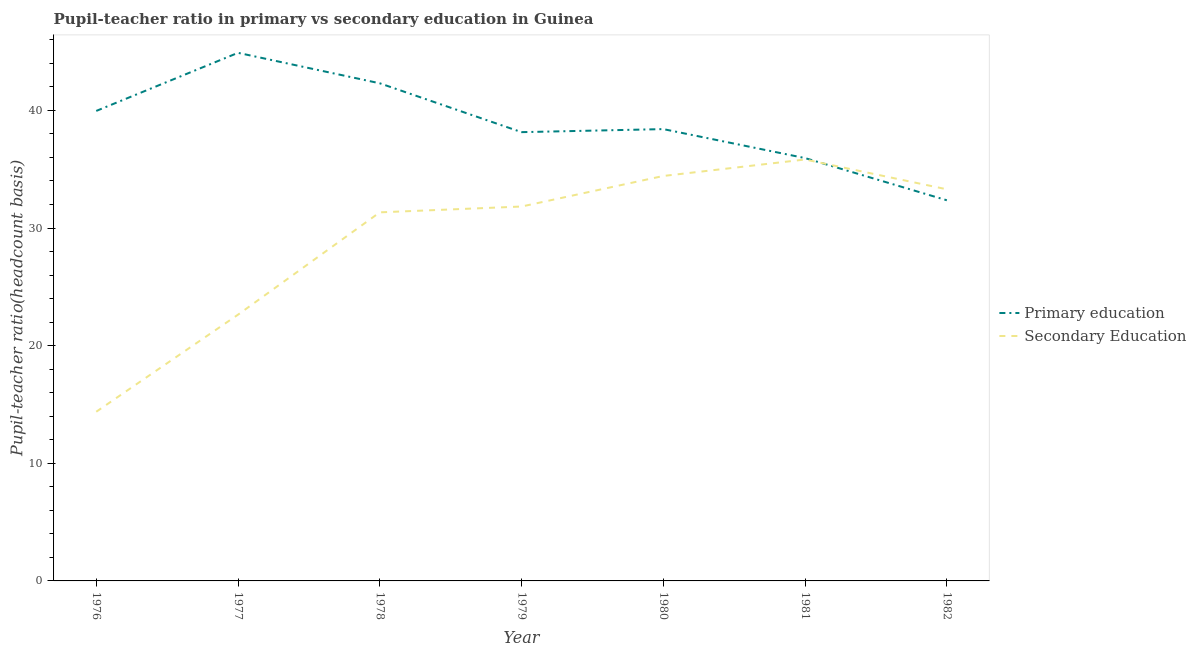How many different coloured lines are there?
Provide a short and direct response. 2. Is the number of lines equal to the number of legend labels?
Offer a terse response. Yes. What is the pupil-teacher ratio in primary education in 1981?
Keep it short and to the point. 35.95. Across all years, what is the maximum pupil teacher ratio on secondary education?
Keep it short and to the point. 35.83. Across all years, what is the minimum pupil-teacher ratio in primary education?
Your response must be concise. 32.36. In which year was the pupil-teacher ratio in primary education maximum?
Offer a very short reply. 1977. What is the total pupil teacher ratio on secondary education in the graph?
Give a very brief answer. 203.72. What is the difference between the pupil-teacher ratio in primary education in 1978 and that in 1982?
Offer a very short reply. 9.94. What is the difference between the pupil-teacher ratio in primary education in 1981 and the pupil teacher ratio on secondary education in 1982?
Offer a very short reply. 2.65. What is the average pupil teacher ratio on secondary education per year?
Keep it short and to the point. 29.1. In the year 1979, what is the difference between the pupil-teacher ratio in primary education and pupil teacher ratio on secondary education?
Your answer should be compact. 6.32. What is the ratio of the pupil-teacher ratio in primary education in 1976 to that in 1978?
Offer a very short reply. 0.94. Is the pupil teacher ratio on secondary education in 1977 less than that in 1979?
Your answer should be very brief. Yes. Is the difference between the pupil teacher ratio on secondary education in 1977 and 1978 greater than the difference between the pupil-teacher ratio in primary education in 1977 and 1978?
Ensure brevity in your answer.  No. What is the difference between the highest and the second highest pupil-teacher ratio in primary education?
Provide a succinct answer. 2.59. What is the difference between the highest and the lowest pupil-teacher ratio in primary education?
Your answer should be very brief. 12.54. Is the pupil teacher ratio on secondary education strictly greater than the pupil-teacher ratio in primary education over the years?
Provide a short and direct response. No. Is the pupil teacher ratio on secondary education strictly less than the pupil-teacher ratio in primary education over the years?
Your answer should be compact. No. What is the difference between two consecutive major ticks on the Y-axis?
Offer a terse response. 10. Does the graph contain grids?
Provide a short and direct response. No. Where does the legend appear in the graph?
Keep it short and to the point. Center right. How are the legend labels stacked?
Your response must be concise. Vertical. What is the title of the graph?
Give a very brief answer. Pupil-teacher ratio in primary vs secondary education in Guinea. What is the label or title of the Y-axis?
Give a very brief answer. Pupil-teacher ratio(headcount basis). What is the Pupil-teacher ratio(headcount basis) of Primary education in 1976?
Your response must be concise. 39.95. What is the Pupil-teacher ratio(headcount basis) of Secondary Education in 1976?
Offer a very short reply. 14.38. What is the Pupil-teacher ratio(headcount basis) in Primary education in 1977?
Offer a terse response. 44.89. What is the Pupil-teacher ratio(headcount basis) of Secondary Education in 1977?
Offer a very short reply. 22.63. What is the Pupil-teacher ratio(headcount basis) in Primary education in 1978?
Your answer should be very brief. 42.3. What is the Pupil-teacher ratio(headcount basis) of Secondary Education in 1978?
Provide a succinct answer. 31.33. What is the Pupil-teacher ratio(headcount basis) of Primary education in 1979?
Your answer should be very brief. 38.15. What is the Pupil-teacher ratio(headcount basis) of Secondary Education in 1979?
Your answer should be very brief. 31.83. What is the Pupil-teacher ratio(headcount basis) in Primary education in 1980?
Provide a short and direct response. 38.41. What is the Pupil-teacher ratio(headcount basis) in Secondary Education in 1980?
Make the answer very short. 34.43. What is the Pupil-teacher ratio(headcount basis) in Primary education in 1981?
Provide a short and direct response. 35.95. What is the Pupil-teacher ratio(headcount basis) of Secondary Education in 1981?
Offer a terse response. 35.83. What is the Pupil-teacher ratio(headcount basis) in Primary education in 1982?
Keep it short and to the point. 32.36. What is the Pupil-teacher ratio(headcount basis) of Secondary Education in 1982?
Ensure brevity in your answer.  33.29. Across all years, what is the maximum Pupil-teacher ratio(headcount basis) of Primary education?
Offer a very short reply. 44.89. Across all years, what is the maximum Pupil-teacher ratio(headcount basis) in Secondary Education?
Offer a terse response. 35.83. Across all years, what is the minimum Pupil-teacher ratio(headcount basis) of Primary education?
Offer a very short reply. 32.36. Across all years, what is the minimum Pupil-teacher ratio(headcount basis) in Secondary Education?
Your answer should be very brief. 14.38. What is the total Pupil-teacher ratio(headcount basis) of Primary education in the graph?
Provide a short and direct response. 272.01. What is the total Pupil-teacher ratio(headcount basis) in Secondary Education in the graph?
Offer a very short reply. 203.72. What is the difference between the Pupil-teacher ratio(headcount basis) of Primary education in 1976 and that in 1977?
Provide a short and direct response. -4.94. What is the difference between the Pupil-teacher ratio(headcount basis) in Secondary Education in 1976 and that in 1977?
Keep it short and to the point. -8.25. What is the difference between the Pupil-teacher ratio(headcount basis) of Primary education in 1976 and that in 1978?
Keep it short and to the point. -2.35. What is the difference between the Pupil-teacher ratio(headcount basis) in Secondary Education in 1976 and that in 1978?
Offer a terse response. -16.95. What is the difference between the Pupil-teacher ratio(headcount basis) in Primary education in 1976 and that in 1979?
Give a very brief answer. 1.8. What is the difference between the Pupil-teacher ratio(headcount basis) of Secondary Education in 1976 and that in 1979?
Make the answer very short. -17.45. What is the difference between the Pupil-teacher ratio(headcount basis) of Primary education in 1976 and that in 1980?
Give a very brief answer. 1.54. What is the difference between the Pupil-teacher ratio(headcount basis) in Secondary Education in 1976 and that in 1980?
Make the answer very short. -20.04. What is the difference between the Pupil-teacher ratio(headcount basis) in Primary education in 1976 and that in 1981?
Give a very brief answer. 4.01. What is the difference between the Pupil-teacher ratio(headcount basis) of Secondary Education in 1976 and that in 1981?
Your answer should be compact. -21.44. What is the difference between the Pupil-teacher ratio(headcount basis) of Primary education in 1976 and that in 1982?
Your response must be concise. 7.6. What is the difference between the Pupil-teacher ratio(headcount basis) in Secondary Education in 1976 and that in 1982?
Provide a short and direct response. -18.91. What is the difference between the Pupil-teacher ratio(headcount basis) of Primary education in 1977 and that in 1978?
Provide a succinct answer. 2.59. What is the difference between the Pupil-teacher ratio(headcount basis) in Secondary Education in 1977 and that in 1978?
Provide a succinct answer. -8.7. What is the difference between the Pupil-teacher ratio(headcount basis) in Primary education in 1977 and that in 1979?
Give a very brief answer. 6.74. What is the difference between the Pupil-teacher ratio(headcount basis) in Secondary Education in 1977 and that in 1979?
Your answer should be compact. -9.19. What is the difference between the Pupil-teacher ratio(headcount basis) in Primary education in 1977 and that in 1980?
Provide a short and direct response. 6.49. What is the difference between the Pupil-teacher ratio(headcount basis) of Secondary Education in 1977 and that in 1980?
Your answer should be very brief. -11.79. What is the difference between the Pupil-teacher ratio(headcount basis) of Primary education in 1977 and that in 1981?
Ensure brevity in your answer.  8.95. What is the difference between the Pupil-teacher ratio(headcount basis) of Secondary Education in 1977 and that in 1981?
Offer a very short reply. -13.19. What is the difference between the Pupil-teacher ratio(headcount basis) of Primary education in 1977 and that in 1982?
Make the answer very short. 12.54. What is the difference between the Pupil-teacher ratio(headcount basis) of Secondary Education in 1977 and that in 1982?
Provide a succinct answer. -10.66. What is the difference between the Pupil-teacher ratio(headcount basis) of Primary education in 1978 and that in 1979?
Make the answer very short. 4.15. What is the difference between the Pupil-teacher ratio(headcount basis) in Secondary Education in 1978 and that in 1979?
Give a very brief answer. -0.49. What is the difference between the Pupil-teacher ratio(headcount basis) of Primary education in 1978 and that in 1980?
Provide a succinct answer. 3.89. What is the difference between the Pupil-teacher ratio(headcount basis) of Secondary Education in 1978 and that in 1980?
Ensure brevity in your answer.  -3.09. What is the difference between the Pupil-teacher ratio(headcount basis) in Primary education in 1978 and that in 1981?
Give a very brief answer. 6.36. What is the difference between the Pupil-teacher ratio(headcount basis) of Secondary Education in 1978 and that in 1981?
Make the answer very short. -4.49. What is the difference between the Pupil-teacher ratio(headcount basis) of Primary education in 1978 and that in 1982?
Ensure brevity in your answer.  9.94. What is the difference between the Pupil-teacher ratio(headcount basis) of Secondary Education in 1978 and that in 1982?
Provide a short and direct response. -1.96. What is the difference between the Pupil-teacher ratio(headcount basis) in Primary education in 1979 and that in 1980?
Your answer should be compact. -0.26. What is the difference between the Pupil-teacher ratio(headcount basis) in Secondary Education in 1979 and that in 1980?
Make the answer very short. -2.6. What is the difference between the Pupil-teacher ratio(headcount basis) of Primary education in 1979 and that in 1981?
Offer a very short reply. 2.21. What is the difference between the Pupil-teacher ratio(headcount basis) in Secondary Education in 1979 and that in 1981?
Your answer should be compact. -4. What is the difference between the Pupil-teacher ratio(headcount basis) of Primary education in 1979 and that in 1982?
Ensure brevity in your answer.  5.79. What is the difference between the Pupil-teacher ratio(headcount basis) of Secondary Education in 1979 and that in 1982?
Give a very brief answer. -1.46. What is the difference between the Pupil-teacher ratio(headcount basis) in Primary education in 1980 and that in 1981?
Keep it short and to the point. 2.46. What is the difference between the Pupil-teacher ratio(headcount basis) of Secondary Education in 1980 and that in 1981?
Make the answer very short. -1.4. What is the difference between the Pupil-teacher ratio(headcount basis) in Primary education in 1980 and that in 1982?
Offer a very short reply. 6.05. What is the difference between the Pupil-teacher ratio(headcount basis) of Secondary Education in 1980 and that in 1982?
Make the answer very short. 1.13. What is the difference between the Pupil-teacher ratio(headcount basis) in Primary education in 1981 and that in 1982?
Offer a terse response. 3.59. What is the difference between the Pupil-teacher ratio(headcount basis) of Secondary Education in 1981 and that in 1982?
Offer a terse response. 2.53. What is the difference between the Pupil-teacher ratio(headcount basis) in Primary education in 1976 and the Pupil-teacher ratio(headcount basis) in Secondary Education in 1977?
Offer a terse response. 17.32. What is the difference between the Pupil-teacher ratio(headcount basis) of Primary education in 1976 and the Pupil-teacher ratio(headcount basis) of Secondary Education in 1978?
Your answer should be very brief. 8.62. What is the difference between the Pupil-teacher ratio(headcount basis) of Primary education in 1976 and the Pupil-teacher ratio(headcount basis) of Secondary Education in 1979?
Provide a short and direct response. 8.13. What is the difference between the Pupil-teacher ratio(headcount basis) in Primary education in 1976 and the Pupil-teacher ratio(headcount basis) in Secondary Education in 1980?
Give a very brief answer. 5.53. What is the difference between the Pupil-teacher ratio(headcount basis) of Primary education in 1976 and the Pupil-teacher ratio(headcount basis) of Secondary Education in 1981?
Provide a short and direct response. 4.13. What is the difference between the Pupil-teacher ratio(headcount basis) in Primary education in 1976 and the Pupil-teacher ratio(headcount basis) in Secondary Education in 1982?
Give a very brief answer. 6.66. What is the difference between the Pupil-teacher ratio(headcount basis) of Primary education in 1977 and the Pupil-teacher ratio(headcount basis) of Secondary Education in 1978?
Make the answer very short. 13.56. What is the difference between the Pupil-teacher ratio(headcount basis) in Primary education in 1977 and the Pupil-teacher ratio(headcount basis) in Secondary Education in 1979?
Give a very brief answer. 13.07. What is the difference between the Pupil-teacher ratio(headcount basis) in Primary education in 1977 and the Pupil-teacher ratio(headcount basis) in Secondary Education in 1980?
Ensure brevity in your answer.  10.47. What is the difference between the Pupil-teacher ratio(headcount basis) in Primary education in 1977 and the Pupil-teacher ratio(headcount basis) in Secondary Education in 1981?
Make the answer very short. 9.07. What is the difference between the Pupil-teacher ratio(headcount basis) of Primary education in 1977 and the Pupil-teacher ratio(headcount basis) of Secondary Education in 1982?
Provide a short and direct response. 11.6. What is the difference between the Pupil-teacher ratio(headcount basis) in Primary education in 1978 and the Pupil-teacher ratio(headcount basis) in Secondary Education in 1979?
Your answer should be very brief. 10.48. What is the difference between the Pupil-teacher ratio(headcount basis) of Primary education in 1978 and the Pupil-teacher ratio(headcount basis) of Secondary Education in 1980?
Provide a succinct answer. 7.88. What is the difference between the Pupil-teacher ratio(headcount basis) of Primary education in 1978 and the Pupil-teacher ratio(headcount basis) of Secondary Education in 1981?
Keep it short and to the point. 6.48. What is the difference between the Pupil-teacher ratio(headcount basis) of Primary education in 1978 and the Pupil-teacher ratio(headcount basis) of Secondary Education in 1982?
Your answer should be compact. 9.01. What is the difference between the Pupil-teacher ratio(headcount basis) of Primary education in 1979 and the Pupil-teacher ratio(headcount basis) of Secondary Education in 1980?
Keep it short and to the point. 3.73. What is the difference between the Pupil-teacher ratio(headcount basis) in Primary education in 1979 and the Pupil-teacher ratio(headcount basis) in Secondary Education in 1981?
Offer a terse response. 2.32. What is the difference between the Pupil-teacher ratio(headcount basis) of Primary education in 1979 and the Pupil-teacher ratio(headcount basis) of Secondary Education in 1982?
Make the answer very short. 4.86. What is the difference between the Pupil-teacher ratio(headcount basis) of Primary education in 1980 and the Pupil-teacher ratio(headcount basis) of Secondary Education in 1981?
Offer a terse response. 2.58. What is the difference between the Pupil-teacher ratio(headcount basis) in Primary education in 1980 and the Pupil-teacher ratio(headcount basis) in Secondary Education in 1982?
Your response must be concise. 5.12. What is the difference between the Pupil-teacher ratio(headcount basis) in Primary education in 1981 and the Pupil-teacher ratio(headcount basis) in Secondary Education in 1982?
Provide a succinct answer. 2.65. What is the average Pupil-teacher ratio(headcount basis) of Primary education per year?
Keep it short and to the point. 38.86. What is the average Pupil-teacher ratio(headcount basis) in Secondary Education per year?
Make the answer very short. 29.1. In the year 1976, what is the difference between the Pupil-teacher ratio(headcount basis) in Primary education and Pupil-teacher ratio(headcount basis) in Secondary Education?
Provide a short and direct response. 25.57. In the year 1977, what is the difference between the Pupil-teacher ratio(headcount basis) of Primary education and Pupil-teacher ratio(headcount basis) of Secondary Education?
Provide a succinct answer. 22.26. In the year 1978, what is the difference between the Pupil-teacher ratio(headcount basis) in Primary education and Pupil-teacher ratio(headcount basis) in Secondary Education?
Keep it short and to the point. 10.97. In the year 1979, what is the difference between the Pupil-teacher ratio(headcount basis) in Primary education and Pupil-teacher ratio(headcount basis) in Secondary Education?
Make the answer very short. 6.32. In the year 1980, what is the difference between the Pupil-teacher ratio(headcount basis) in Primary education and Pupil-teacher ratio(headcount basis) in Secondary Education?
Make the answer very short. 3.98. In the year 1981, what is the difference between the Pupil-teacher ratio(headcount basis) in Primary education and Pupil-teacher ratio(headcount basis) in Secondary Education?
Keep it short and to the point. 0.12. In the year 1982, what is the difference between the Pupil-teacher ratio(headcount basis) in Primary education and Pupil-teacher ratio(headcount basis) in Secondary Education?
Your answer should be very brief. -0.93. What is the ratio of the Pupil-teacher ratio(headcount basis) of Primary education in 1976 to that in 1977?
Your answer should be very brief. 0.89. What is the ratio of the Pupil-teacher ratio(headcount basis) of Secondary Education in 1976 to that in 1977?
Your answer should be very brief. 0.64. What is the ratio of the Pupil-teacher ratio(headcount basis) of Primary education in 1976 to that in 1978?
Keep it short and to the point. 0.94. What is the ratio of the Pupil-teacher ratio(headcount basis) of Secondary Education in 1976 to that in 1978?
Your response must be concise. 0.46. What is the ratio of the Pupil-teacher ratio(headcount basis) of Primary education in 1976 to that in 1979?
Give a very brief answer. 1.05. What is the ratio of the Pupil-teacher ratio(headcount basis) in Secondary Education in 1976 to that in 1979?
Offer a very short reply. 0.45. What is the ratio of the Pupil-teacher ratio(headcount basis) of Primary education in 1976 to that in 1980?
Offer a terse response. 1.04. What is the ratio of the Pupil-teacher ratio(headcount basis) of Secondary Education in 1976 to that in 1980?
Offer a very short reply. 0.42. What is the ratio of the Pupil-teacher ratio(headcount basis) in Primary education in 1976 to that in 1981?
Ensure brevity in your answer.  1.11. What is the ratio of the Pupil-teacher ratio(headcount basis) of Secondary Education in 1976 to that in 1981?
Provide a succinct answer. 0.4. What is the ratio of the Pupil-teacher ratio(headcount basis) of Primary education in 1976 to that in 1982?
Offer a very short reply. 1.23. What is the ratio of the Pupil-teacher ratio(headcount basis) of Secondary Education in 1976 to that in 1982?
Your answer should be very brief. 0.43. What is the ratio of the Pupil-teacher ratio(headcount basis) in Primary education in 1977 to that in 1978?
Make the answer very short. 1.06. What is the ratio of the Pupil-teacher ratio(headcount basis) in Secondary Education in 1977 to that in 1978?
Make the answer very short. 0.72. What is the ratio of the Pupil-teacher ratio(headcount basis) in Primary education in 1977 to that in 1979?
Give a very brief answer. 1.18. What is the ratio of the Pupil-teacher ratio(headcount basis) of Secondary Education in 1977 to that in 1979?
Give a very brief answer. 0.71. What is the ratio of the Pupil-teacher ratio(headcount basis) in Primary education in 1977 to that in 1980?
Give a very brief answer. 1.17. What is the ratio of the Pupil-teacher ratio(headcount basis) of Secondary Education in 1977 to that in 1980?
Keep it short and to the point. 0.66. What is the ratio of the Pupil-teacher ratio(headcount basis) of Primary education in 1977 to that in 1981?
Make the answer very short. 1.25. What is the ratio of the Pupil-teacher ratio(headcount basis) of Secondary Education in 1977 to that in 1981?
Your answer should be compact. 0.63. What is the ratio of the Pupil-teacher ratio(headcount basis) in Primary education in 1977 to that in 1982?
Provide a short and direct response. 1.39. What is the ratio of the Pupil-teacher ratio(headcount basis) of Secondary Education in 1977 to that in 1982?
Your answer should be very brief. 0.68. What is the ratio of the Pupil-teacher ratio(headcount basis) of Primary education in 1978 to that in 1979?
Offer a very short reply. 1.11. What is the ratio of the Pupil-teacher ratio(headcount basis) in Secondary Education in 1978 to that in 1979?
Ensure brevity in your answer.  0.98. What is the ratio of the Pupil-teacher ratio(headcount basis) of Primary education in 1978 to that in 1980?
Offer a very short reply. 1.1. What is the ratio of the Pupil-teacher ratio(headcount basis) in Secondary Education in 1978 to that in 1980?
Provide a succinct answer. 0.91. What is the ratio of the Pupil-teacher ratio(headcount basis) in Primary education in 1978 to that in 1981?
Your response must be concise. 1.18. What is the ratio of the Pupil-teacher ratio(headcount basis) of Secondary Education in 1978 to that in 1981?
Your answer should be very brief. 0.87. What is the ratio of the Pupil-teacher ratio(headcount basis) of Primary education in 1978 to that in 1982?
Offer a very short reply. 1.31. What is the ratio of the Pupil-teacher ratio(headcount basis) of Primary education in 1979 to that in 1980?
Your answer should be very brief. 0.99. What is the ratio of the Pupil-teacher ratio(headcount basis) in Secondary Education in 1979 to that in 1980?
Offer a terse response. 0.92. What is the ratio of the Pupil-teacher ratio(headcount basis) in Primary education in 1979 to that in 1981?
Offer a very short reply. 1.06. What is the ratio of the Pupil-teacher ratio(headcount basis) in Secondary Education in 1979 to that in 1981?
Keep it short and to the point. 0.89. What is the ratio of the Pupil-teacher ratio(headcount basis) of Primary education in 1979 to that in 1982?
Provide a short and direct response. 1.18. What is the ratio of the Pupil-teacher ratio(headcount basis) of Secondary Education in 1979 to that in 1982?
Ensure brevity in your answer.  0.96. What is the ratio of the Pupil-teacher ratio(headcount basis) of Primary education in 1980 to that in 1981?
Your response must be concise. 1.07. What is the ratio of the Pupil-teacher ratio(headcount basis) in Secondary Education in 1980 to that in 1981?
Give a very brief answer. 0.96. What is the ratio of the Pupil-teacher ratio(headcount basis) in Primary education in 1980 to that in 1982?
Provide a succinct answer. 1.19. What is the ratio of the Pupil-teacher ratio(headcount basis) of Secondary Education in 1980 to that in 1982?
Your answer should be compact. 1.03. What is the ratio of the Pupil-teacher ratio(headcount basis) of Primary education in 1981 to that in 1982?
Your answer should be compact. 1.11. What is the ratio of the Pupil-teacher ratio(headcount basis) in Secondary Education in 1981 to that in 1982?
Your response must be concise. 1.08. What is the difference between the highest and the second highest Pupil-teacher ratio(headcount basis) in Primary education?
Provide a short and direct response. 2.59. What is the difference between the highest and the second highest Pupil-teacher ratio(headcount basis) of Secondary Education?
Your response must be concise. 1.4. What is the difference between the highest and the lowest Pupil-teacher ratio(headcount basis) of Primary education?
Your answer should be very brief. 12.54. What is the difference between the highest and the lowest Pupil-teacher ratio(headcount basis) in Secondary Education?
Your answer should be compact. 21.44. 